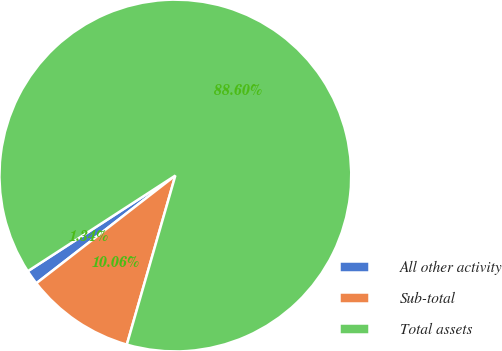Convert chart. <chart><loc_0><loc_0><loc_500><loc_500><pie_chart><fcel>All other activity<fcel>Sub-total<fcel>Total assets<nl><fcel>1.34%<fcel>10.06%<fcel>88.6%<nl></chart> 